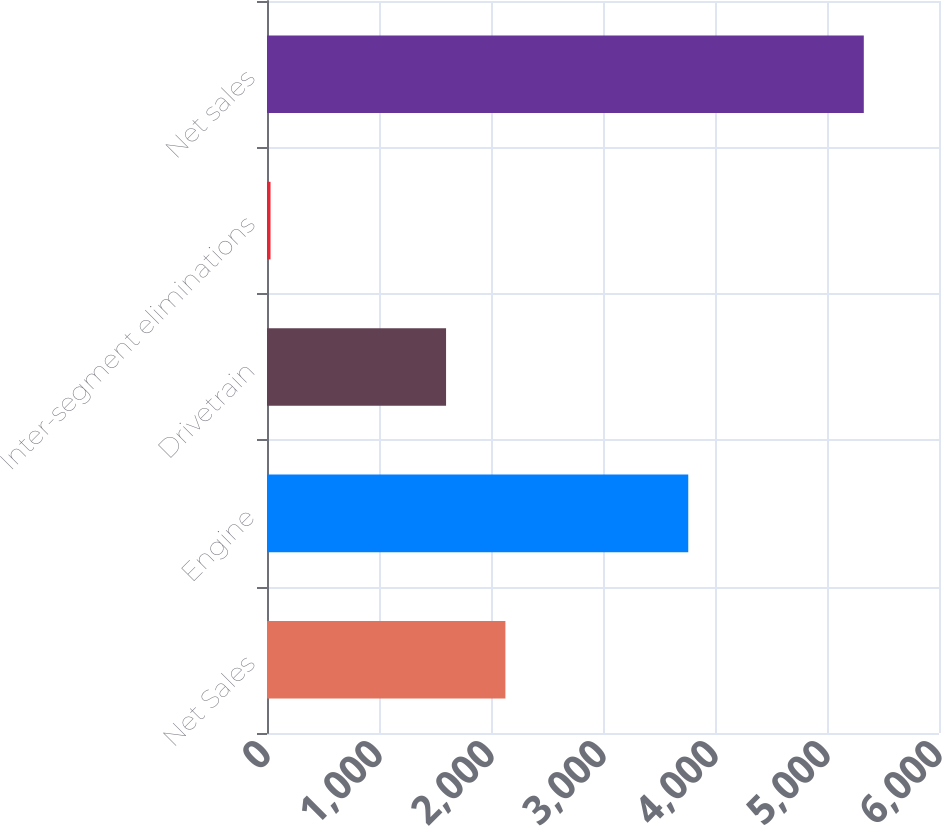Convert chart. <chart><loc_0><loc_0><loc_500><loc_500><bar_chart><fcel>Net Sales<fcel>Engine<fcel>Drivetrain<fcel>Inter-segment eliminations<fcel>Net sales<nl><fcel>2128.51<fcel>3761.3<fcel>1598.8<fcel>31.5<fcel>5328.6<nl></chart> 